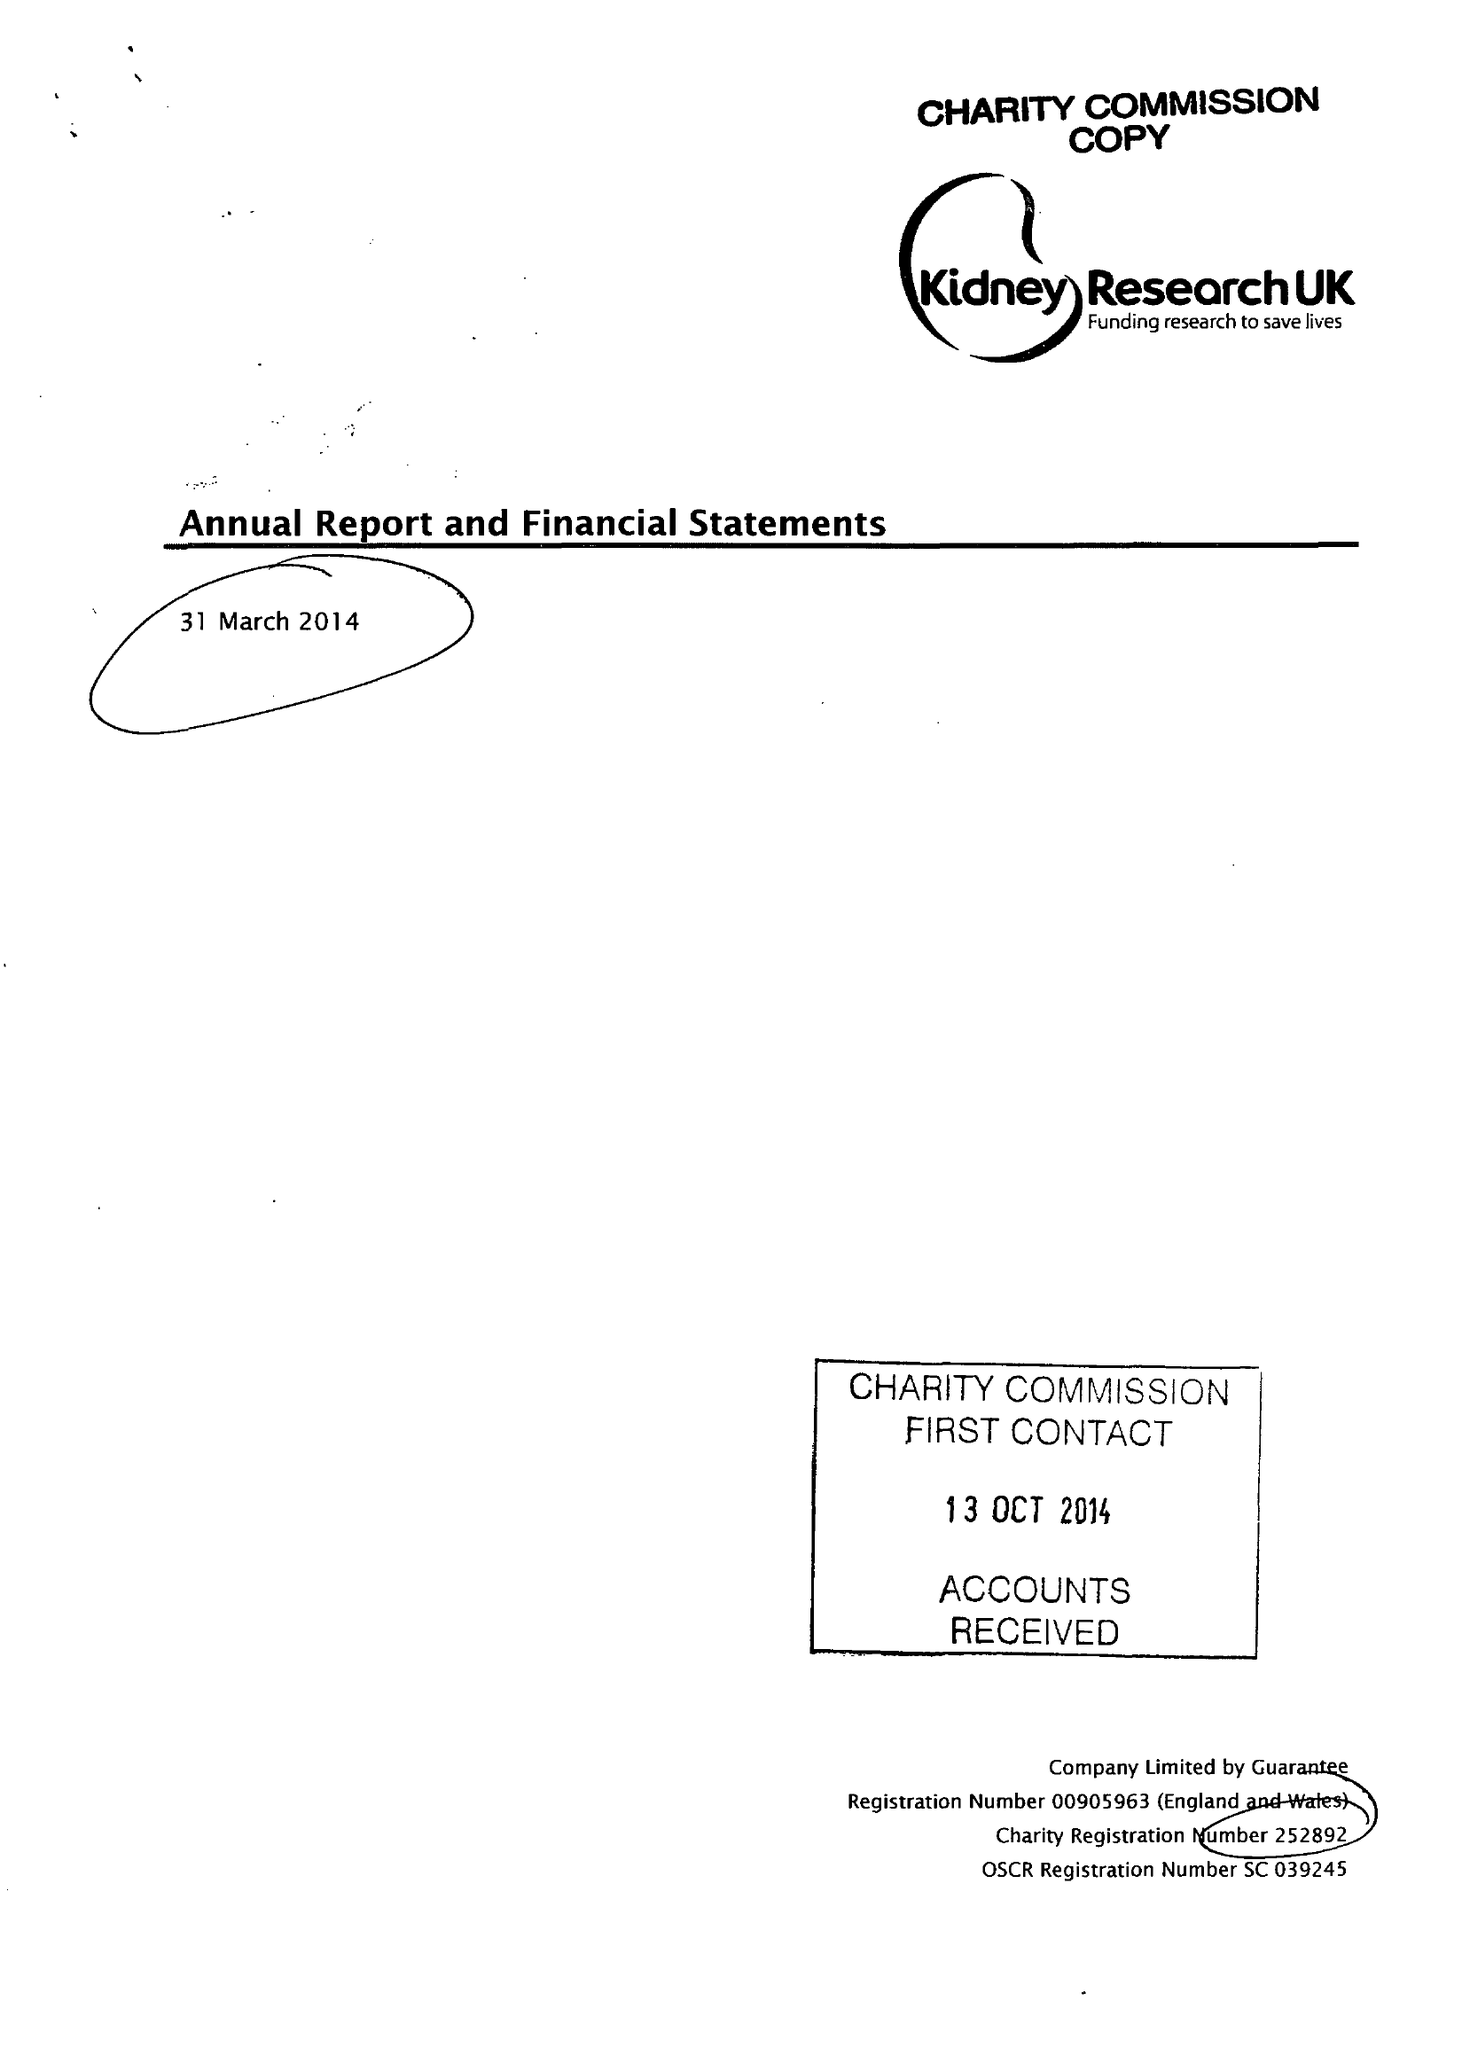What is the value for the income_annually_in_british_pounds?
Answer the question using a single word or phrase. 8356086.00 